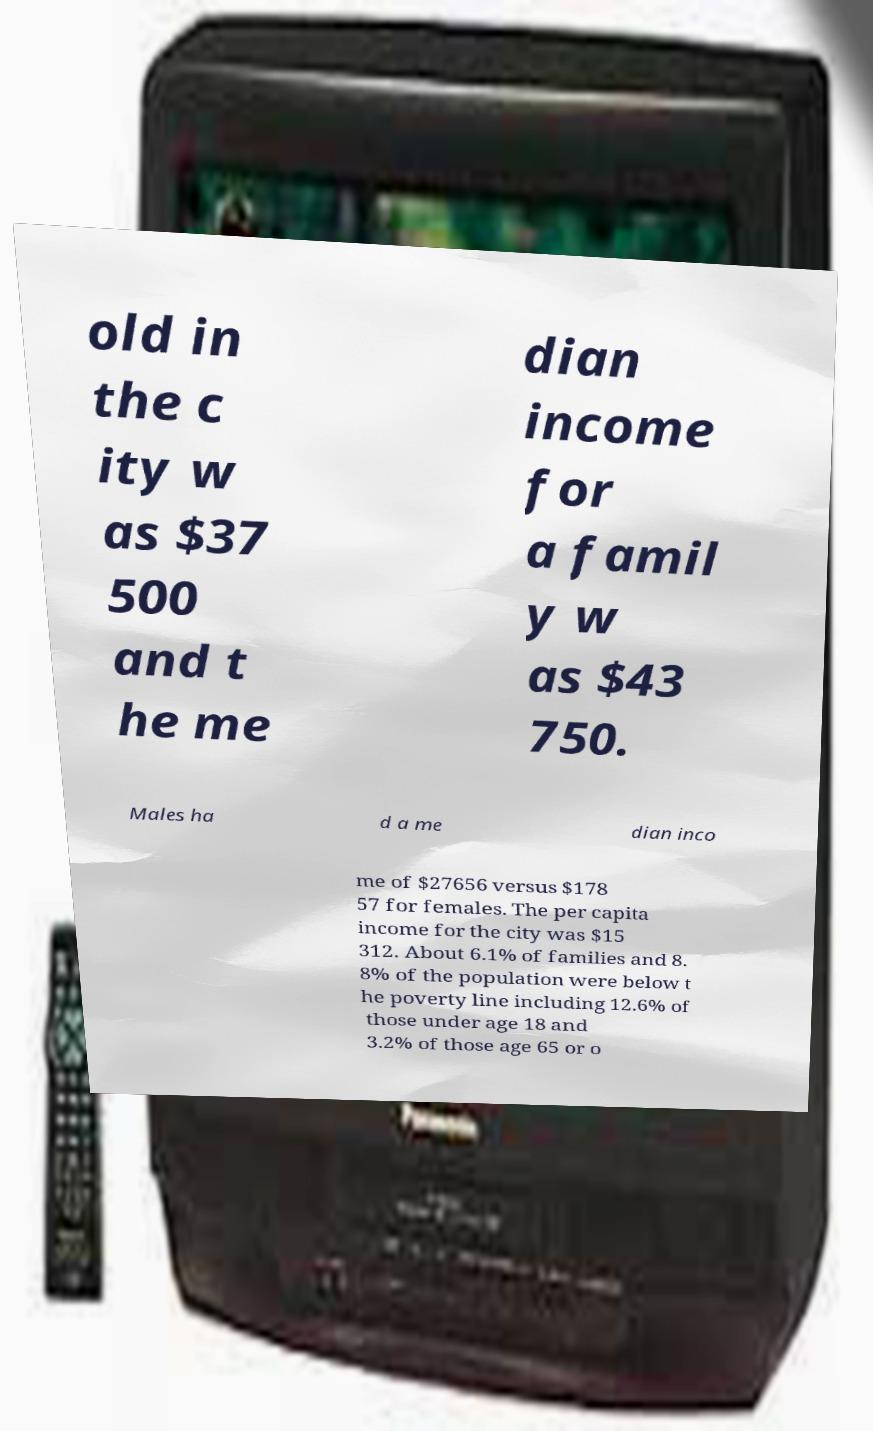I need the written content from this picture converted into text. Can you do that? old in the c ity w as $37 500 and t he me dian income for a famil y w as $43 750. Males ha d a me dian inco me of $27656 versus $178 57 for females. The per capita income for the city was $15 312. About 6.1% of families and 8. 8% of the population were below t he poverty line including 12.6% of those under age 18 and 3.2% of those age 65 or o 